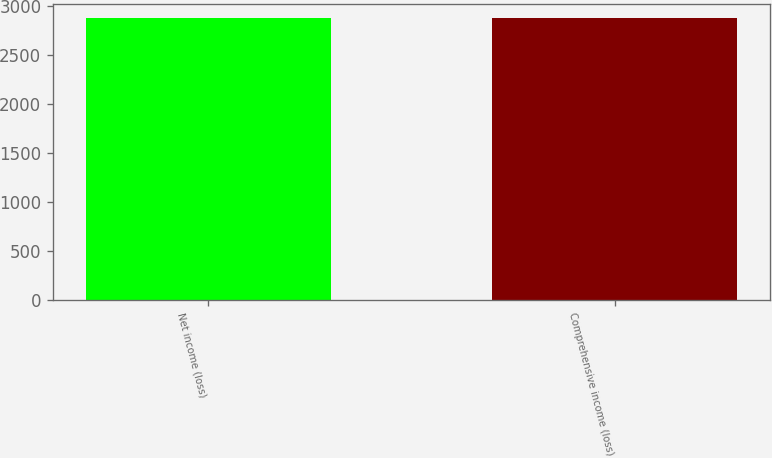Convert chart to OTSL. <chart><loc_0><loc_0><loc_500><loc_500><bar_chart><fcel>Net income (loss)<fcel>Comprehensive income (loss)<nl><fcel>2882<fcel>2883<nl></chart> 